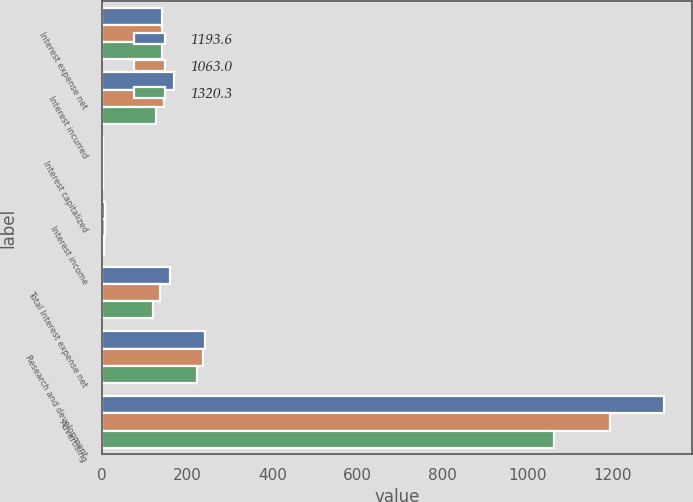<chart> <loc_0><loc_0><loc_500><loc_500><stacked_bar_chart><ecel><fcel>Interest expense net<fcel>Interest incurred<fcel>Interest capitalized<fcel>Interest income<fcel>Total Interest expense net<fcel>Research and development<fcel>Advertising<nl><fcel>1193.6<fcel>140.5<fcel>170<fcel>3.4<fcel>7.9<fcel>158.7<fcel>241.5<fcel>1320.3<nl><fcel>1063<fcel>140.5<fcel>145<fcel>2.5<fcel>6.5<fcel>136<fcel>238.5<fcel>1193.6<nl><fcel>1320.3<fcel>140.5<fcel>126<fcel>2.3<fcel>4<fcel>119.7<fcel>223.4<fcel>1063<nl></chart> 